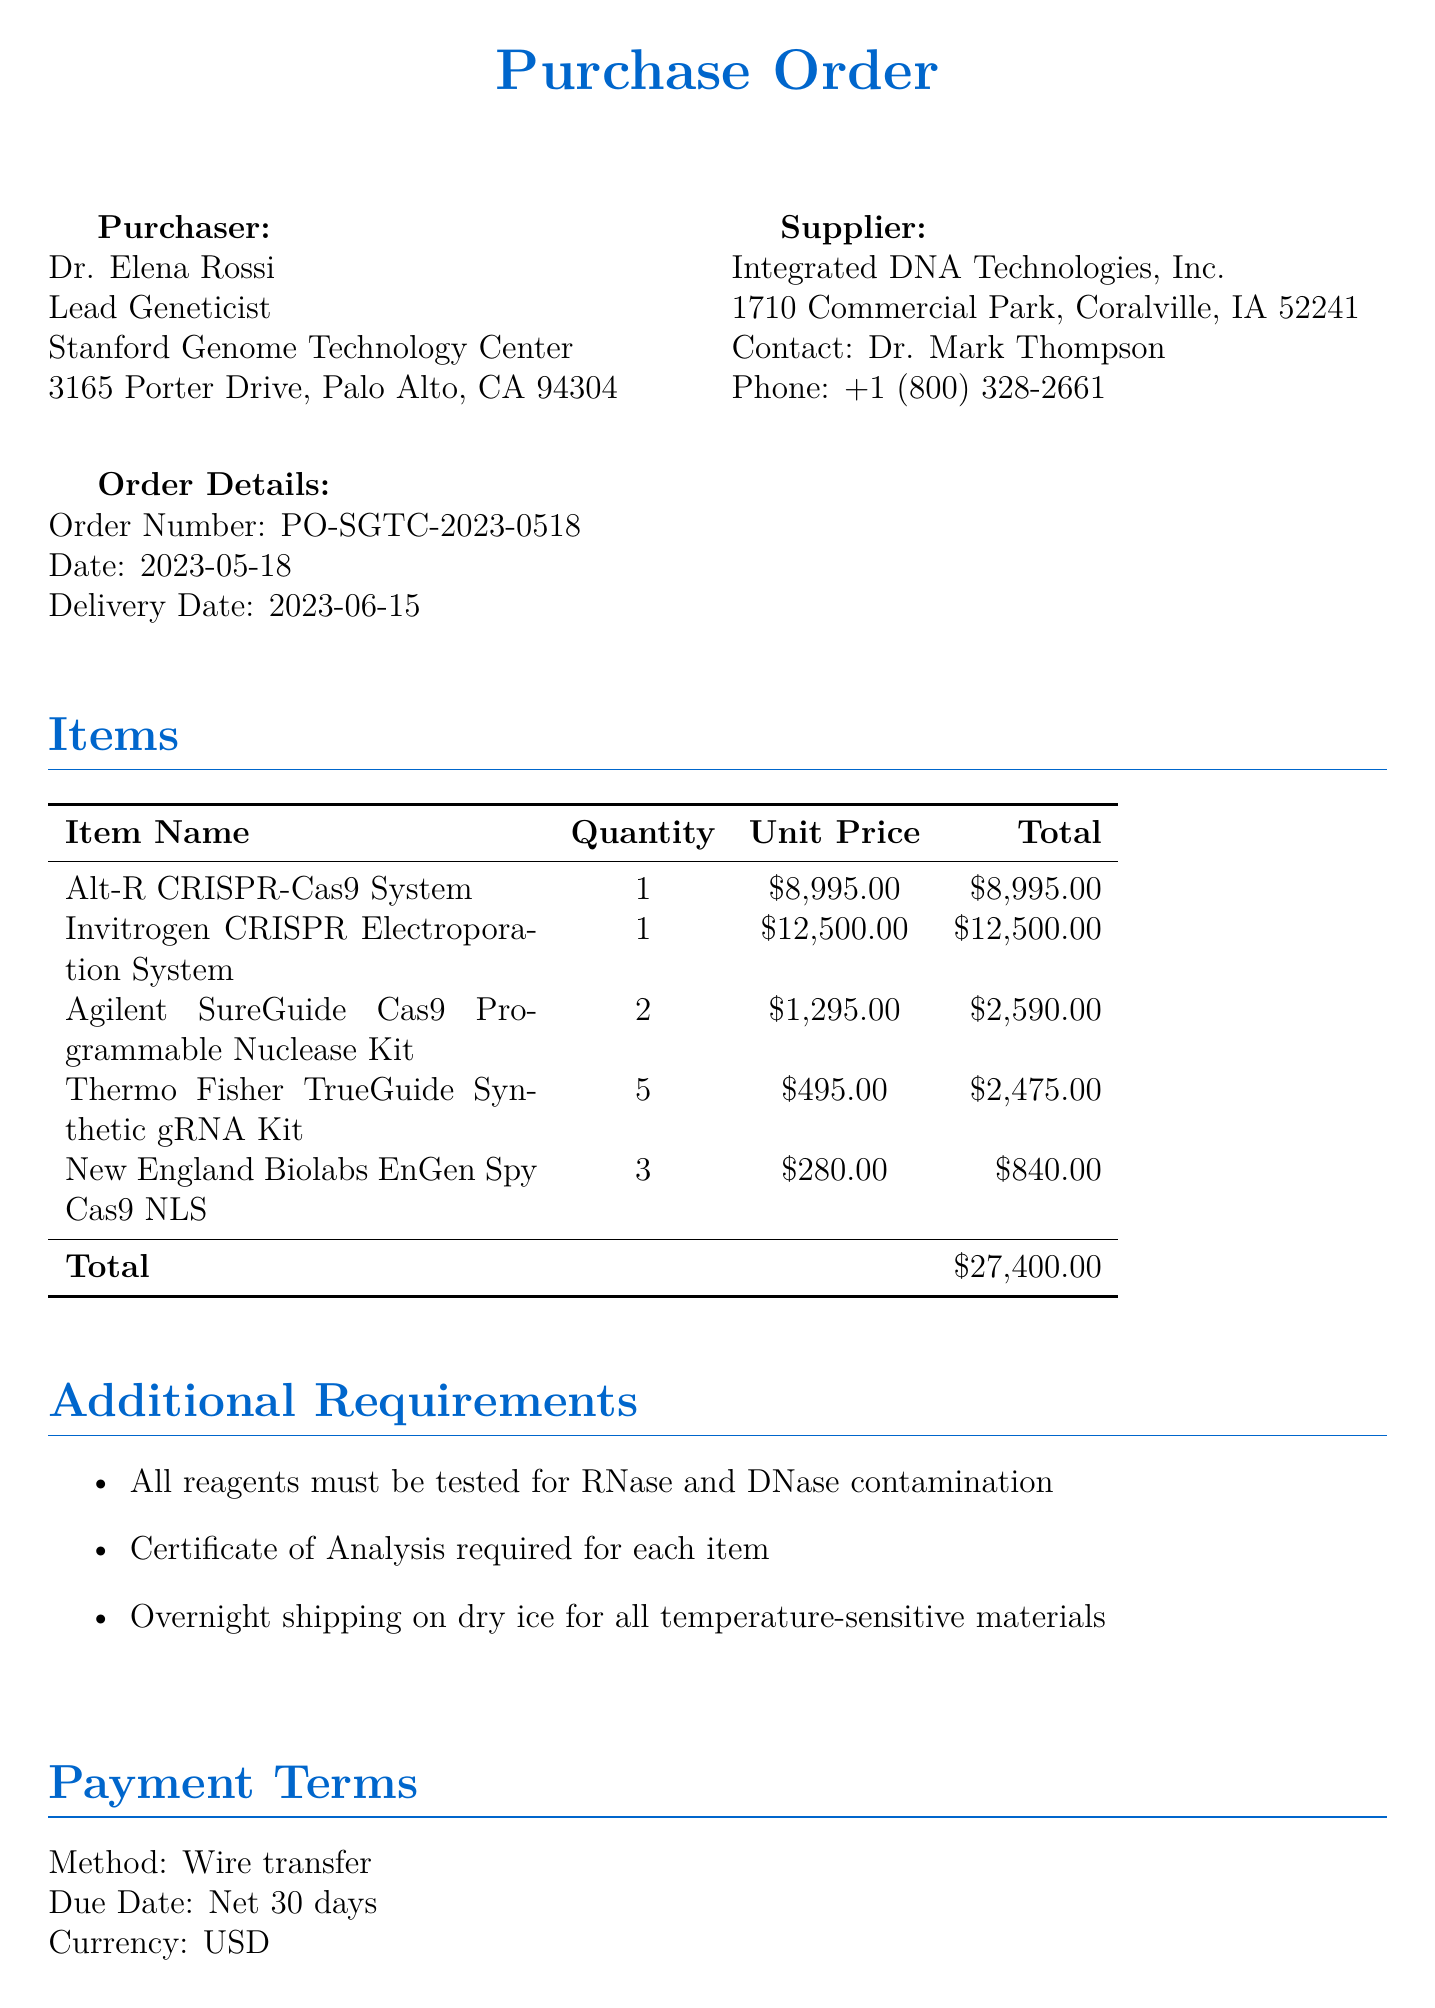What is the name of the purchaser? The purchaser is Dr. Elena Rossi, who is the Lead Geneticist at Stanford Genome Technology Center.
Answer: Dr. Elena Rossi What is the total cost of items ordered? The total cost is the sum of the unit prices multiplied by their quantities, which amounts to $27,400.00.
Answer: $27,400.00 When is the delivery date? The delivery date is specified in the document as June 15, 2023.
Answer: June 15, 2023 How many Thermo Fisher TrueGuide Synthetic gRNA Kits are ordered? The document lists the order quantity for the Thermo Fisher TrueGuide Synthetic gRNA Kit as five.
Answer: 5 What is the payment method? The payment method outlined in the document is wire transfer.
Answer: Wire transfer What is the research purpose mentioned in the document? The research purpose is clearly stated as gene editing for cystic fibrosis therapy development.
Answer: Gene editing for cystic fibrosis therapy development What additional requirement specifies shipping conditions? The additional requirement states that overnight shipping on dry ice is needed for all temperature-sensitive materials.
Answer: Overnight shipping on dry ice How many Agilent SureGuide Cas9 Programmable Nuclease Kits are ordered? The order specifies that two Agilent SureGuide Cas9 Programmable Nuclease Kits are included.
Answer: 2 Who is the contact person at the supplier? The contact person listed at Integrated DNA Technologies, Inc. is Dr. Mark Thompson.
Answer: Dr. Mark Thompson 